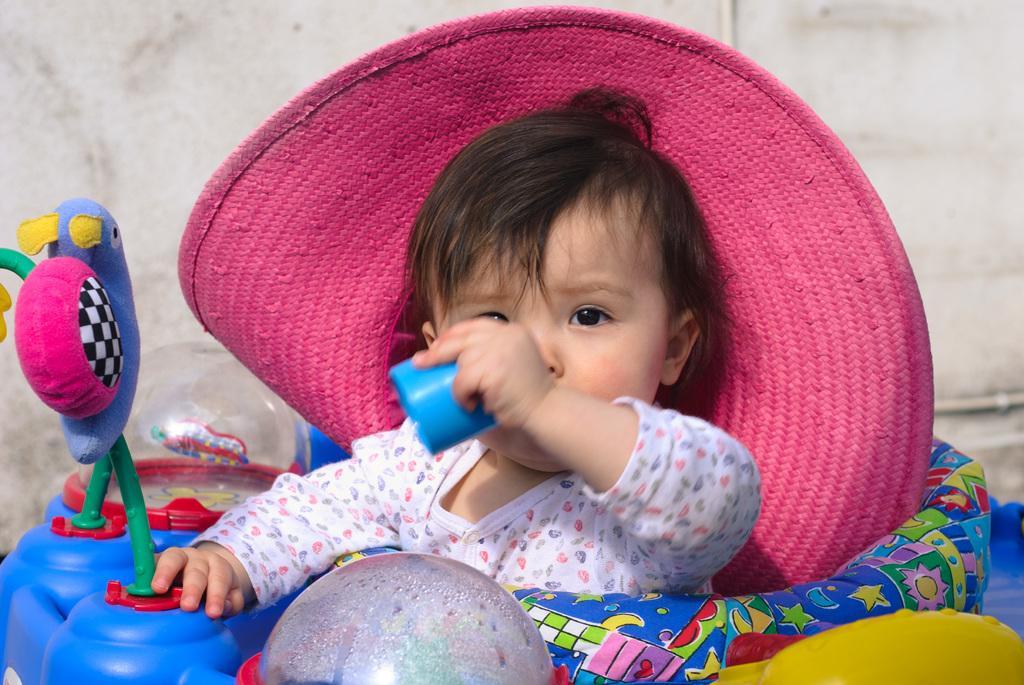Can you describe this image briefly? In this image there is a kid sitting on a toy and wearing a hat, in the background there is a wall. 